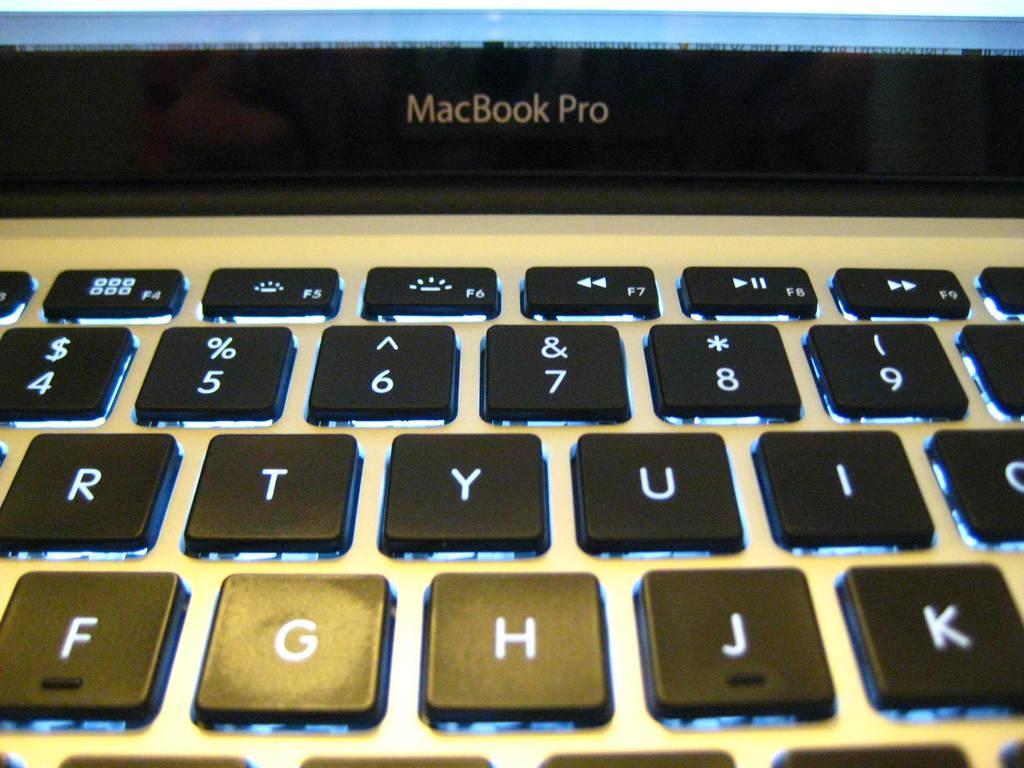Describe this image in one or two sentences. In this image I can see keyboard. I can see a macbook pro laptop. 